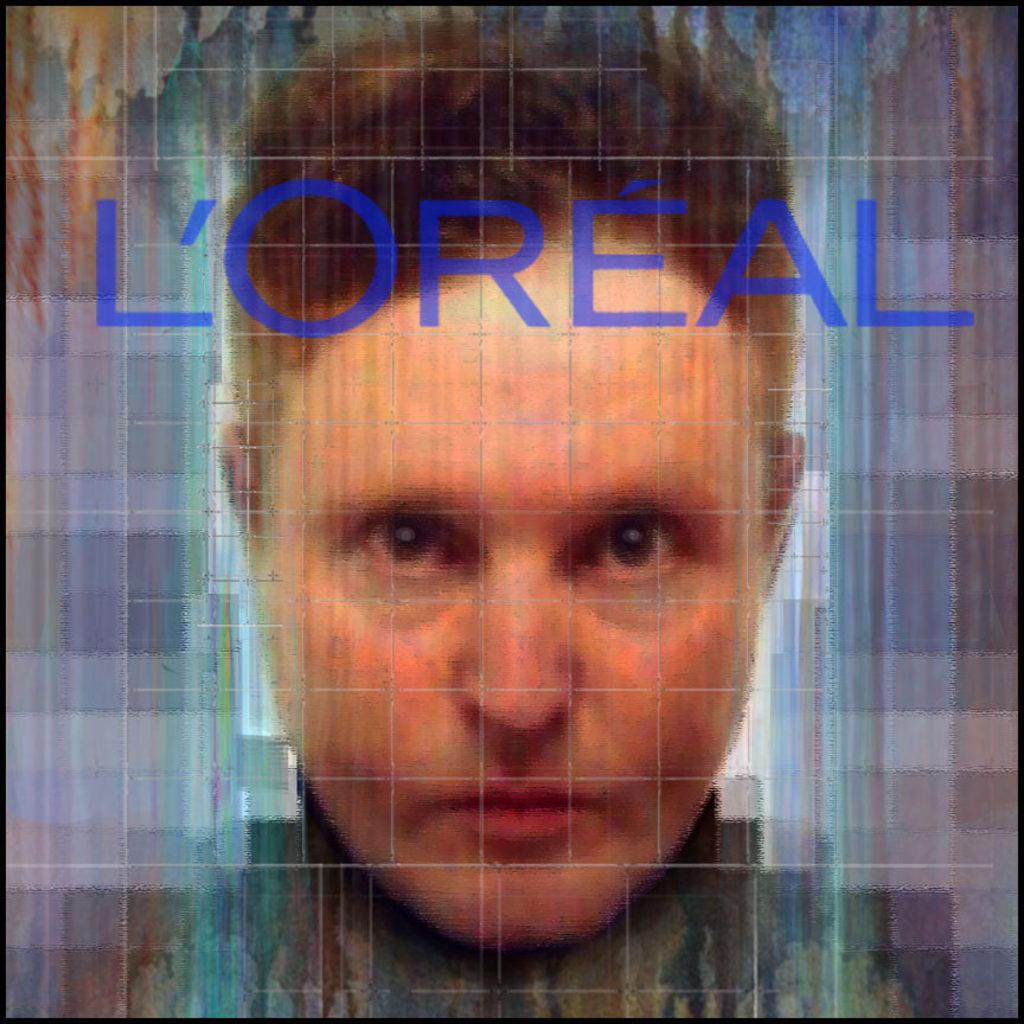What can be observed about the image's appearance? The image is edited. What is the main subject of the image? There is a picture of a person in the image. What text is visible on the picture of the person? The word "L'OREAL" is written on the picture of the person. What type of skate is being used by the person in the image? There is no skate present in the image; it features a picture of a person with the word "L'OREAL" written on it. What subject is the person learning in the image? The image does not depict the person learning a subject; it only shows a picture of a person with the word "L'OREAL" written on it. 